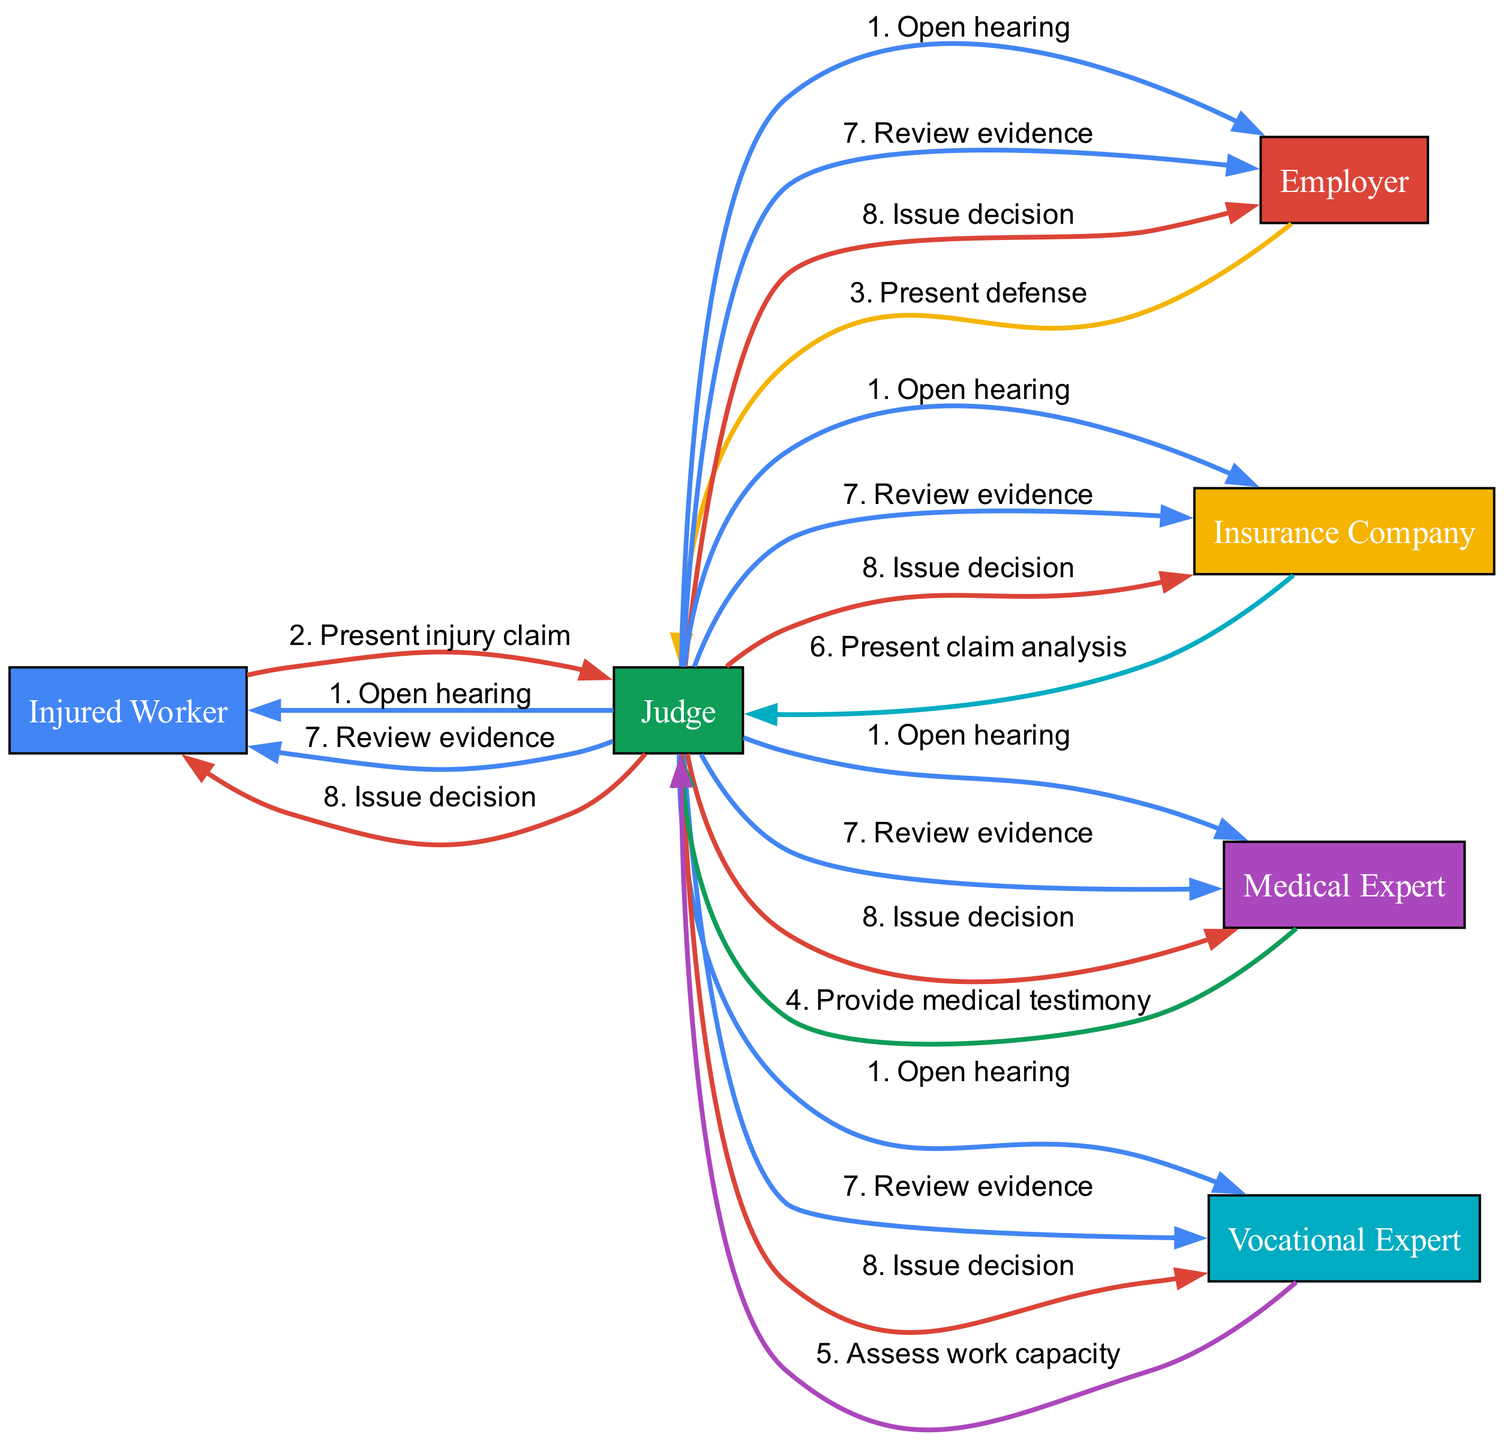What is the first action taken in the hearing? The diagram shows that the first action taken is when the Judge opens the hearing. This is indicated as the first message in the sequence from the Judge to all participants.
Answer: Open hearing How many participants are in the sequence diagram? The diagram lists six participants involved in the sequence of events: Injured Worker, Employer, Insurance Company, Judge, Medical Expert, and Vocational Expert. Therefore, the total number of participants is six.
Answer: Six Who presents the injury claim? According to the sequence diagram, the Injured Worker is the one who presents the injury claim during the hearing. This is shown as their direct communication to the Judge.
Answer: Injured Worker What does the Medical Expert provide during the hearing? The sequence indicates that the Medical Expert provides medical testimony to the Judge. This is a specific action in the diagram clearly associated with the Medical Expert's role.
Answer: Provide medical testimony How many steps involve the Judge communicating with all participants? In the sequence, the Judge has two steps where they communicate with all participants—first by opening the hearing and second by issuing a decision. This involves analyzing the flow of the diagram and counting such interactions.
Answer: Two Which participant assesses work capacity? The sequence diagram shows that the Vocational Expert is responsible for assessing the work capacity during the hearing. This is highlighted in their interaction with the Judge.
Answer: Vocational Expert What is the final action in the diagram? The final action in the diagram is when the Judge issues a decision. This occurs after reviewing the evidence and represents the conclusion of the hearing process.
Answer: Issue decision How does the Insurance Company contribute to the hearing? The Insurance Company participates by presenting a claim analysis to the Judge. This indicates their role in providing relevant information regarding the claim being assessed.
Answer: Present claim analysis What role does the Judge have throughout the diagram? The Judge's role encompasses opening the hearing, receiving presentations from various participants, reviewing evidence, and finally issuing a decision. The Judge acts as a central figure coordinating the hearing process.
Answer: Central figure 